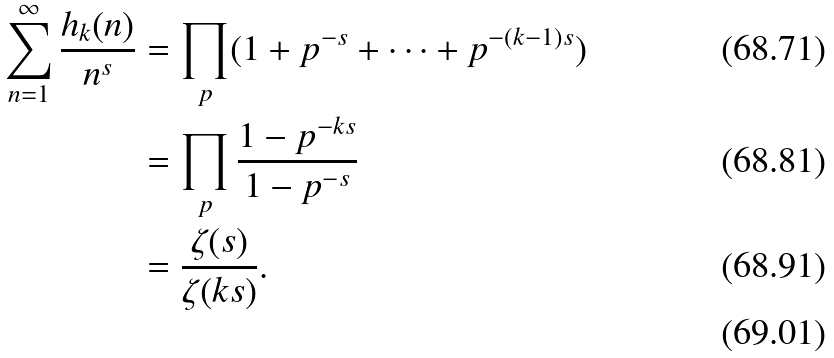Convert formula to latex. <formula><loc_0><loc_0><loc_500><loc_500>\sum _ { n = 1 } ^ { \infty } \frac { h _ { k } ( n ) } { n ^ { s } } & = \prod _ { p } ( 1 + p ^ { - s } + \cdots + p ^ { - ( k - 1 ) s } ) \\ & = \prod _ { p } \frac { 1 - p ^ { - k s } } { 1 - p ^ { - s } } \\ & = \frac { \zeta ( s ) } { \zeta ( k s ) } . \\</formula> 